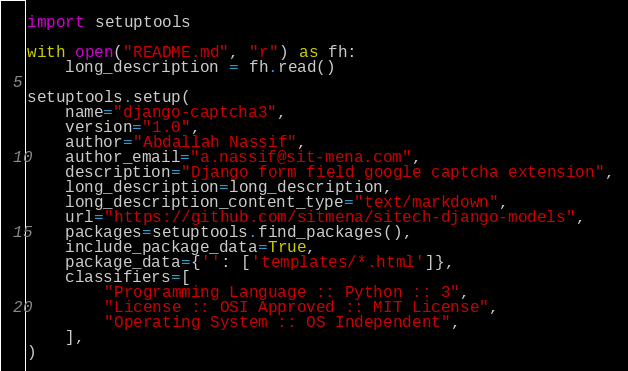<code> <loc_0><loc_0><loc_500><loc_500><_Python_>import setuptools

with open("README.md", "r") as fh:
    long_description = fh.read()

setuptools.setup(
    name="django-captcha3",
    version="1.0",
    author="Abdallah Nassif",
    author_email="a.nassif@sit-mena.com",
    description="Django form field google captcha extension",
    long_description=long_description,
    long_description_content_type="text/markdown",
    url="https://github.com/sitmena/sitech-django-models",
    packages=setuptools.find_packages(),
    include_package_data=True,
    package_data={'': ['templates/*.html']},
    classifiers=[
        "Programming Language :: Python :: 3",
        "License :: OSI Approved :: MIT License",
        "Operating System :: OS Independent",
    ],
)
</code> 